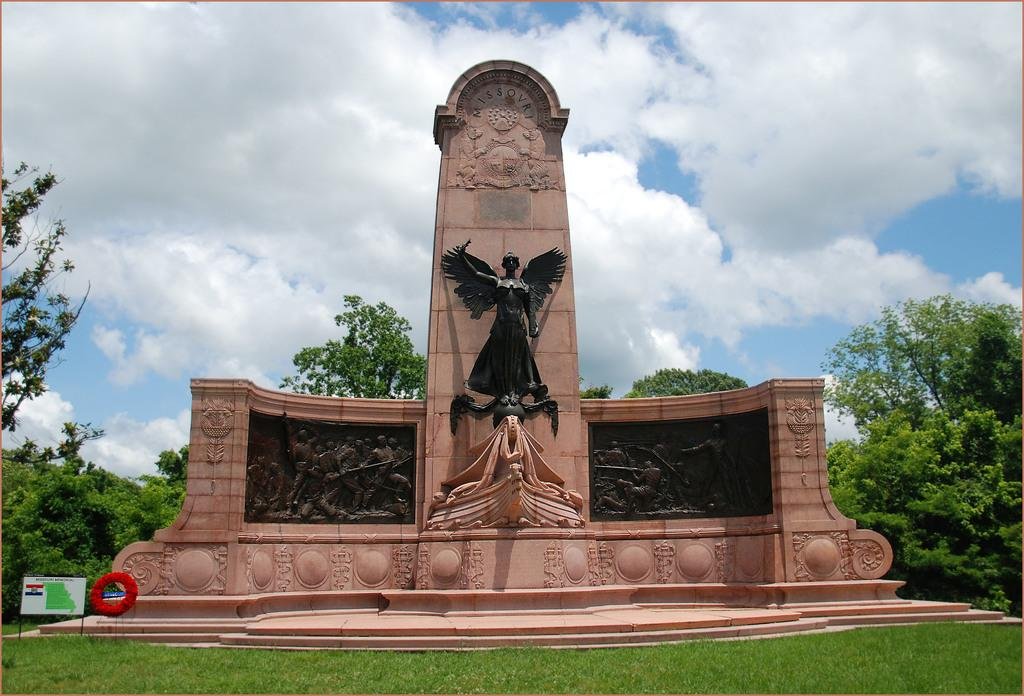What is the main subject in the middle of the image? There is a statue in the middle of the image. What type of ground is visible at the bottom of the image? There is grass at the bottom of the image. What can be seen in the background of the image? Trees and the sky are visible in the background of the image. Where is the scarecrow located in the image? There is no scarecrow present in the image. What type of brush is used to paint the statue in the image? The image does not provide information about the materials or techniques used to create the statue. 